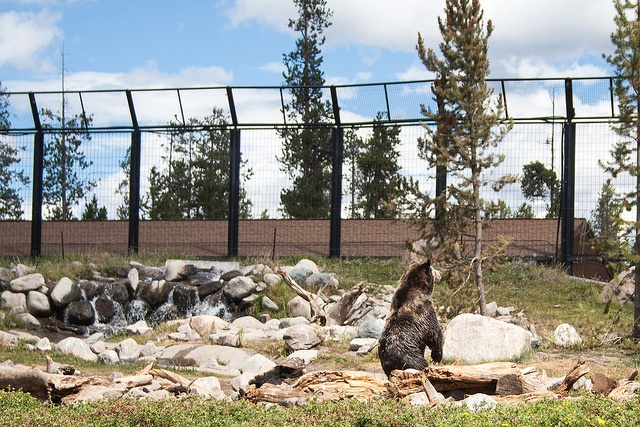Describe the objects in this image and their specific colors. I can see a bear in lightblue, black, and gray tones in this image. 